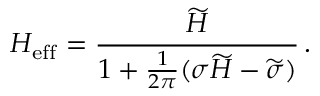<formula> <loc_0><loc_0><loc_500><loc_500>H _ { e f f } = \frac { \widetilde { H } } { 1 + \frac { 1 } { 2 \pi } ( \sigma \widetilde { H } - \widetilde { \sigma } ) } \, .</formula> 